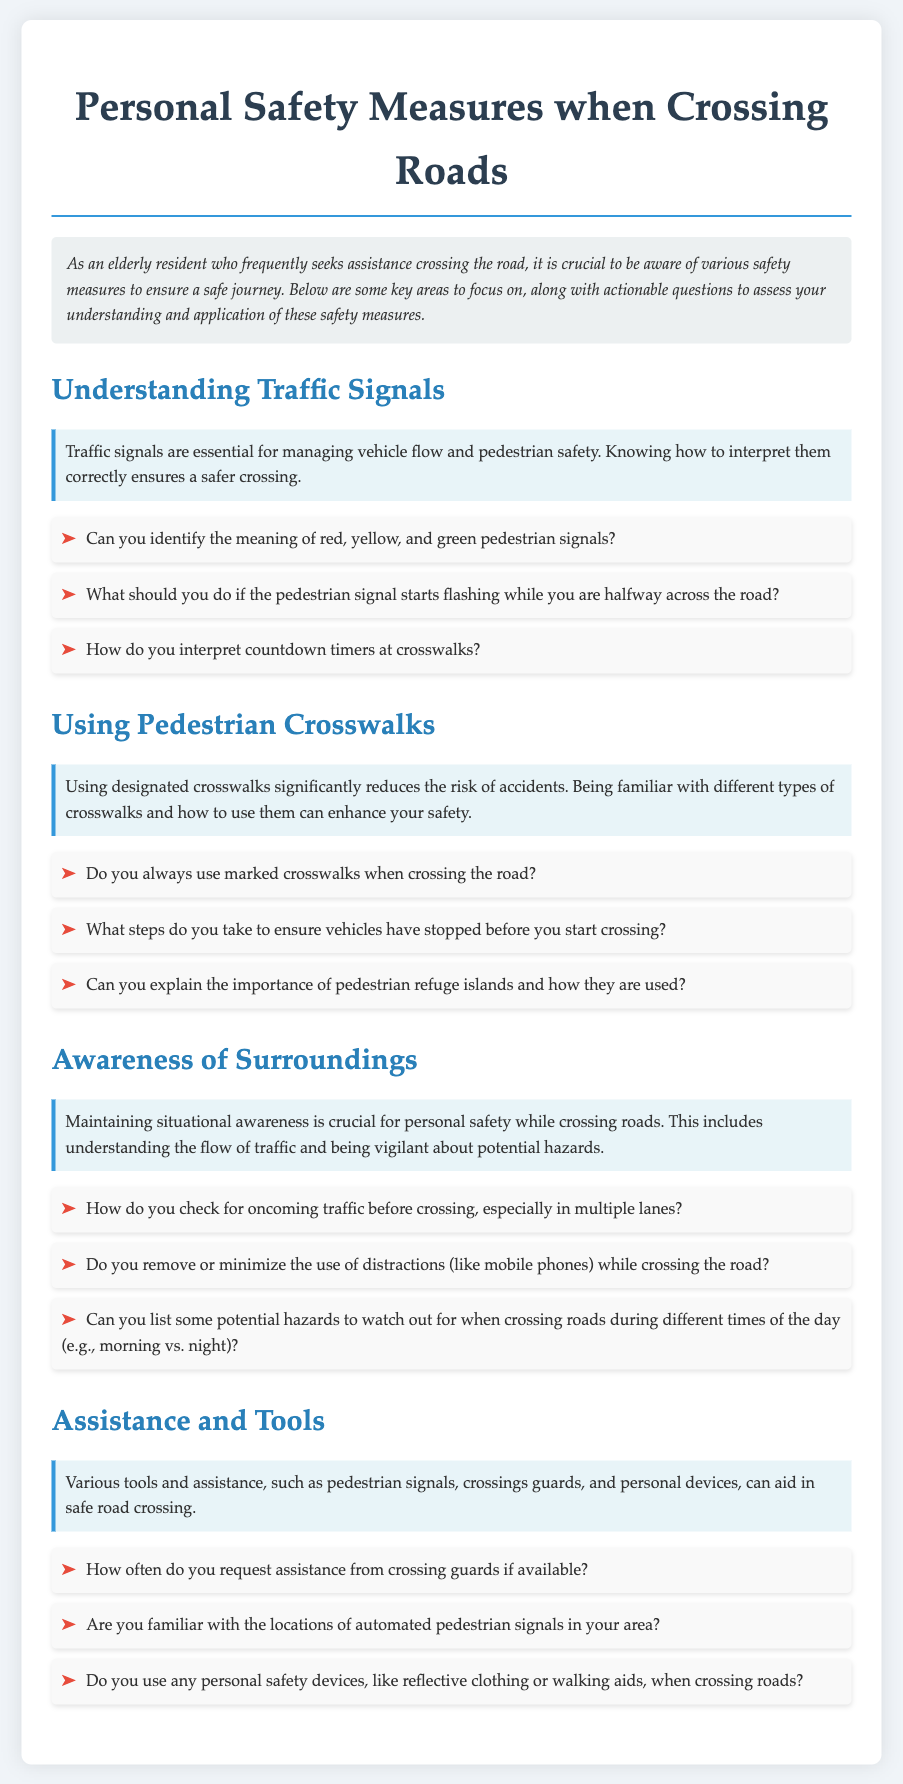Can you identify the meaning of red pedestrian signal? This question retrieves specific information about traffic signals from the document that explains their meanings.
Answer: Stop What should you do if the pedestrian signal starts flashing while you are halfway across the road? This question asks for information regarding actions to take in a specific situation related to pedestrian signals.
Answer: Wait What steps do you take to ensure vehicles have stopped before you start crossing? This question examines the understanding of safety measures related to using designated crosswalks in the document.
Answer: Look both ways How do you check for oncoming traffic before crossing? This question assesses knowledge of situational awareness as highlighted in the document, requiring reasoning about traffic flow.
Answer: Look left and right Can you list some potential hazards to watch out for when crossing roads during different times of the day? This question combines elements from the document regarding awareness of surroundings and risks associated with crossing roads at different times.
Answer: Poor visibility How often do you request assistance from crossing guards if available? This question inquires about the frequency of seeking help when crossing, which is specified under the assistance section.
Answer: Regularly Are you familiar with the locations of automated pedestrian signals in your area? This question probes knowledge about specific tools utilized for pedestrian safety, as discussed in the document.
Answer: Yes Do you use any personal safety devices when crossing roads? This question addresses the use of assistance tools mentioned in the section about assistance and tools.
Answer: Yes Can you explain the importance of pedestrian refuge islands? This question encourages reasoning about safety measures by requiring explanation of their significance based on information in the document.
Answer: They provide a safe spot to wait 